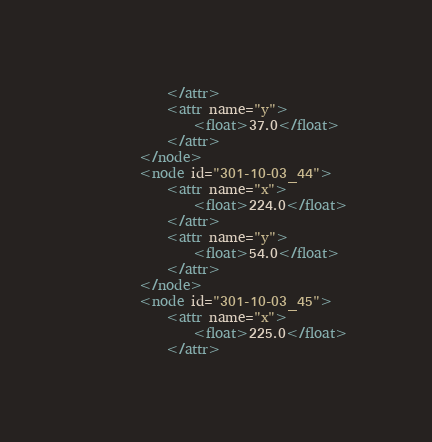Convert code to text. <code><loc_0><loc_0><loc_500><loc_500><_XML_>			</attr>
			<attr name="y">
				<float>37.0</float>
			</attr>
		</node>
		<node id="301-10-03_44">
			<attr name="x">
				<float>224.0</float>
			</attr>
			<attr name="y">
				<float>54.0</float>
			</attr>
		</node>
		<node id="301-10-03_45">
			<attr name="x">
				<float>225.0</float>
			</attr></code> 